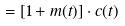Convert formula to latex. <formula><loc_0><loc_0><loc_500><loc_500>= [ 1 + m ( t ) ] \cdot c ( t )</formula> 